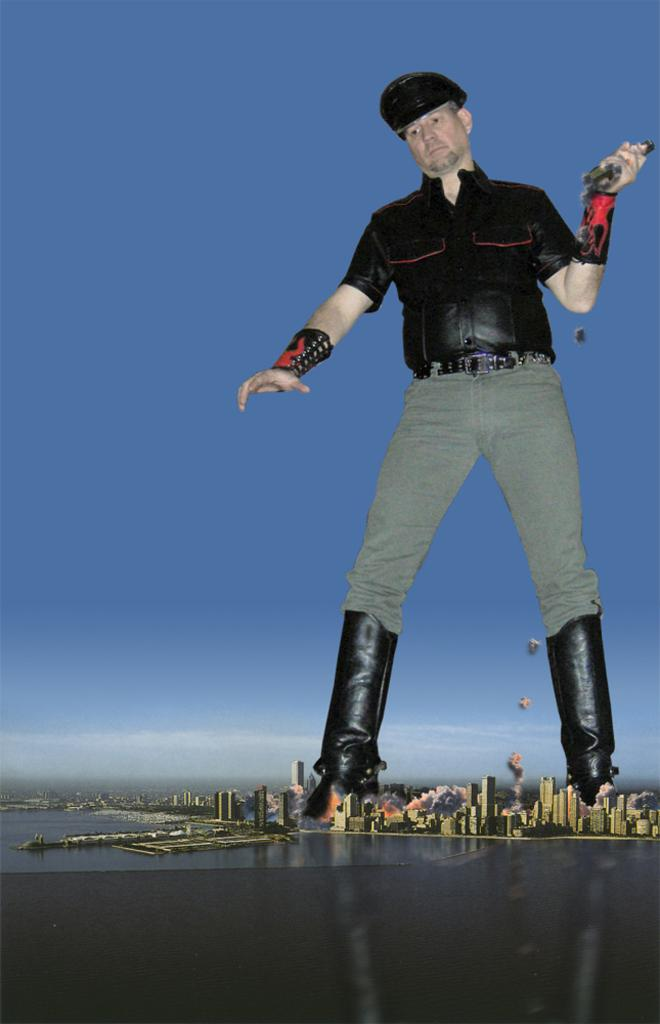What is the main subject of the image? There is a man in the image. What is the man doing in the image? The man is holding an object. Where is the man standing in the image? The man is standing on the ground. What can be seen in the background of the image? The sky is visible in the background of the image. What else is present in the image besides the man? There is water, buildings, and other objects visible in the image. What type of pies can be seen in the image? There are no pies present in the image. How does the man communicate with the ground in the image? The man is standing on the ground, so there is no need for him to communicate with it. 